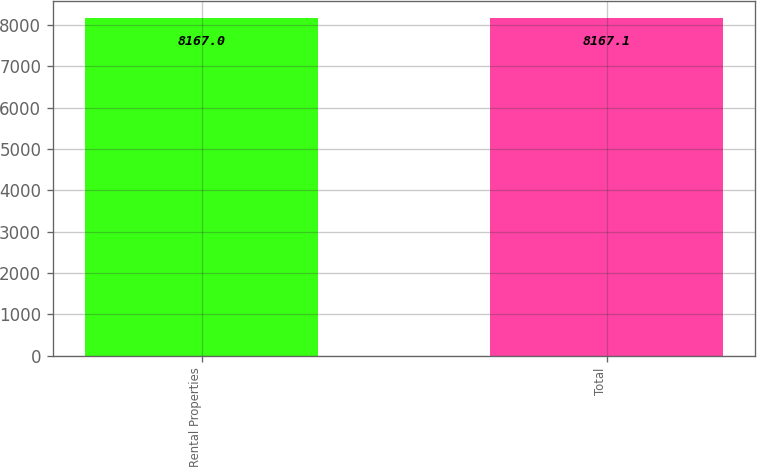Convert chart. <chart><loc_0><loc_0><loc_500><loc_500><bar_chart><fcel>Rental Properties<fcel>Total<nl><fcel>8167<fcel>8167.1<nl></chart> 